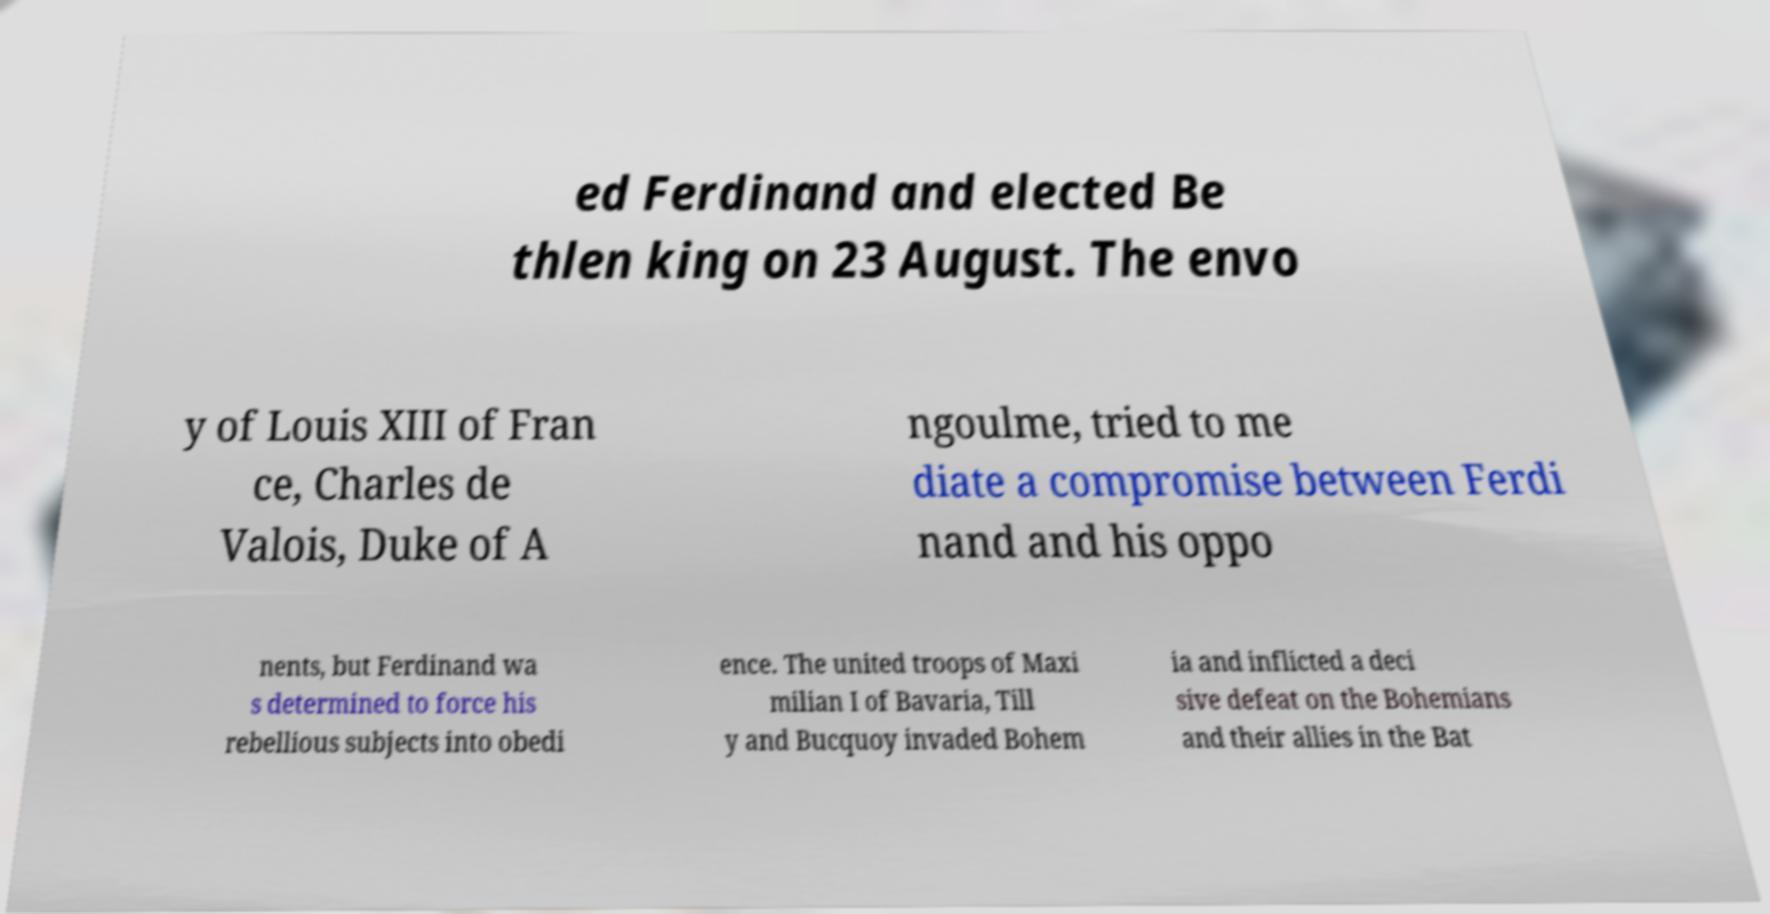Please read and relay the text visible in this image. What does it say? ed Ferdinand and elected Be thlen king on 23 August. The envo y of Louis XIII of Fran ce, Charles de Valois, Duke of A ngoulme, tried to me diate a compromise between Ferdi nand and his oppo nents, but Ferdinand wa s determined to force his rebellious subjects into obedi ence. The united troops of Maxi milian I of Bavaria, Till y and Bucquoy invaded Bohem ia and inflicted a deci sive defeat on the Bohemians and their allies in the Bat 